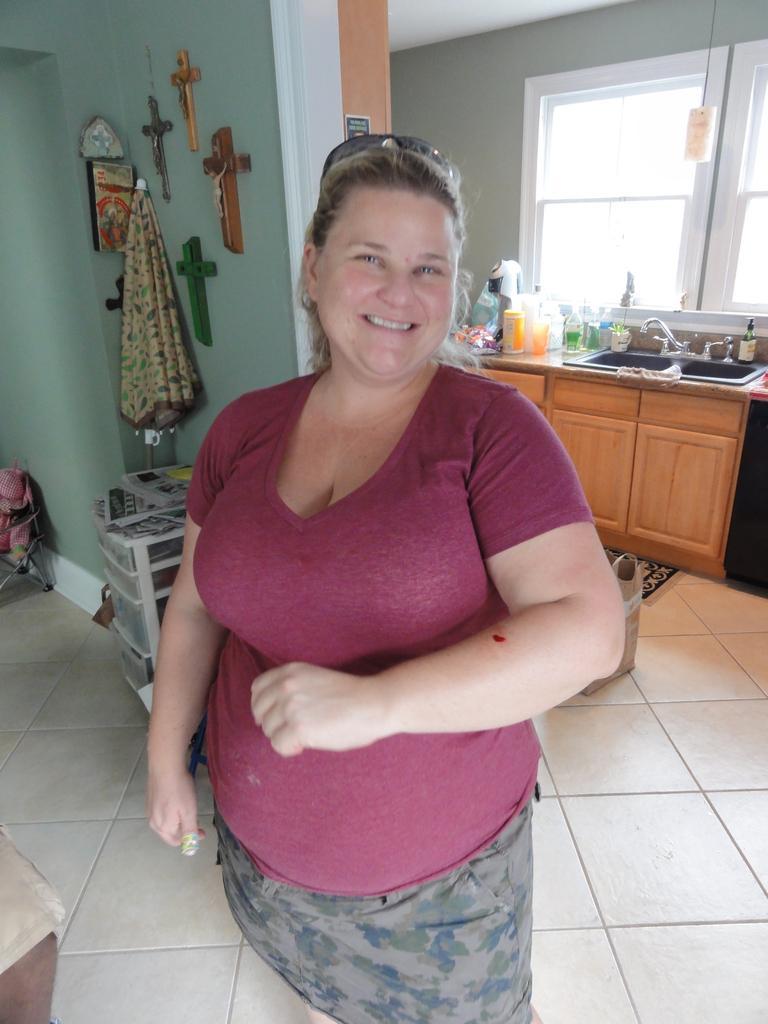In one or two sentences, can you explain what this image depicts? In this image I can see a woman is standing and smiling. The woman is wearing a t-shirt and shades. Here I can see crosses and some other objects attached to the wall. Here I can see a kitchen top on which I can see bottles, sink which has taps and other objects. Here I can see windows and some objects on the floor. 